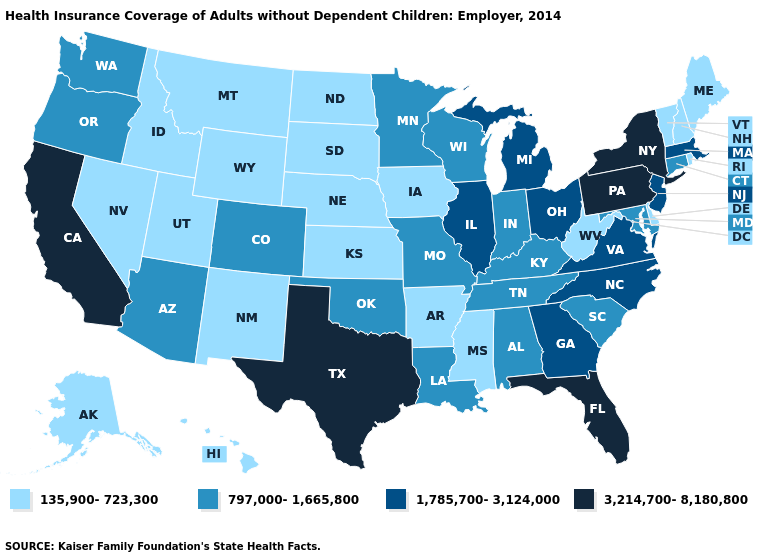What is the highest value in the USA?
Answer briefly. 3,214,700-8,180,800. What is the value of Georgia?
Keep it brief. 1,785,700-3,124,000. Name the states that have a value in the range 135,900-723,300?
Keep it brief. Alaska, Arkansas, Delaware, Hawaii, Idaho, Iowa, Kansas, Maine, Mississippi, Montana, Nebraska, Nevada, New Hampshire, New Mexico, North Dakota, Rhode Island, South Dakota, Utah, Vermont, West Virginia, Wyoming. Name the states that have a value in the range 135,900-723,300?
Concise answer only. Alaska, Arkansas, Delaware, Hawaii, Idaho, Iowa, Kansas, Maine, Mississippi, Montana, Nebraska, Nevada, New Hampshire, New Mexico, North Dakota, Rhode Island, South Dakota, Utah, Vermont, West Virginia, Wyoming. What is the highest value in the MidWest ?
Be succinct. 1,785,700-3,124,000. Name the states that have a value in the range 135,900-723,300?
Concise answer only. Alaska, Arkansas, Delaware, Hawaii, Idaho, Iowa, Kansas, Maine, Mississippi, Montana, Nebraska, Nevada, New Hampshire, New Mexico, North Dakota, Rhode Island, South Dakota, Utah, Vermont, West Virginia, Wyoming. Among the states that border Texas , does Arkansas have the highest value?
Keep it brief. No. Is the legend a continuous bar?
Concise answer only. No. What is the lowest value in the West?
Concise answer only. 135,900-723,300. What is the lowest value in the USA?
Short answer required. 135,900-723,300. What is the highest value in the MidWest ?
Answer briefly. 1,785,700-3,124,000. What is the value of Georgia?
Keep it brief. 1,785,700-3,124,000. What is the value of Nevada?
Concise answer only. 135,900-723,300. What is the value of West Virginia?
Short answer required. 135,900-723,300. Does Colorado have a higher value than Montana?
Give a very brief answer. Yes. 